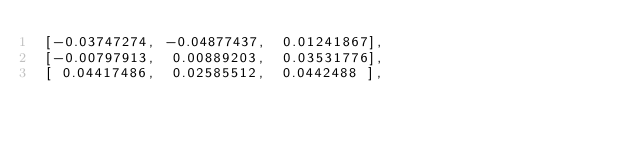<code> <loc_0><loc_0><loc_500><loc_500><_Python_> [-0.03747274, -0.04877437,  0.01241867],
 [-0.00797913,  0.00889203,  0.03531776],
 [ 0.04417486,  0.02585512,  0.0442488 ],</code> 